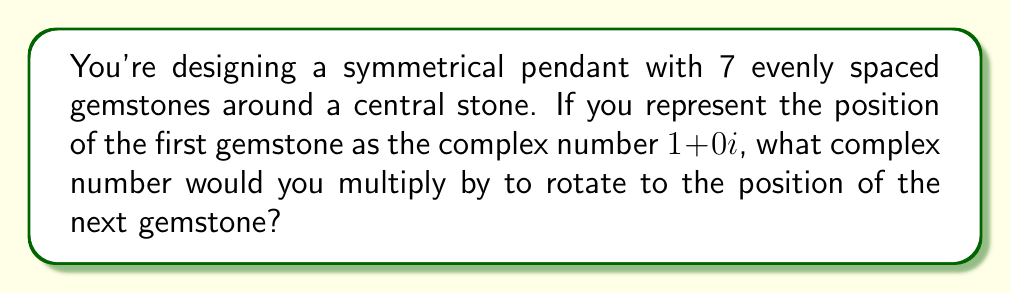Give your solution to this math problem. To solve this problem, we'll follow these steps:

1) In a symmetrical design with 7 evenly spaced gemstones, the angle between each gemstone is:

   $$\theta = \frac{360°}{7} \approx 51.43°$$

2) To rotate a point in the complex plane by an angle $\theta$, we multiply by $\cos\theta + i\sin\theta$. This is known as the complex rotation formula.

3) For our angle:

   $$\cos(51.43°) + i\sin(51.43°)$$

4) We can simplify this using Euler's formula: $e^{i\theta} = \cos\theta + i\sin\theta$

   $$e^{i(2\pi/7)}$$

5) This complex number, when multiplied by the position of any gemstone, will rotate it to the position of the next gemstone in the sequence.

[asy]
import geometry;

unitsize(50);
dot((0,0));
for(int k=0; k<7; ++k) {
  real angle = 2*pi*k/7;
  dot((cos(angle), sin(angle)));
}
draw(circle((0,0), 1));
label("1+0i", (1,0), E);
label("e^(2πi/7)", (cos(2*pi/7), sin(2*pi/7)), NE);
[/asy]
Answer: $e^{i(2\pi/7)}$ 